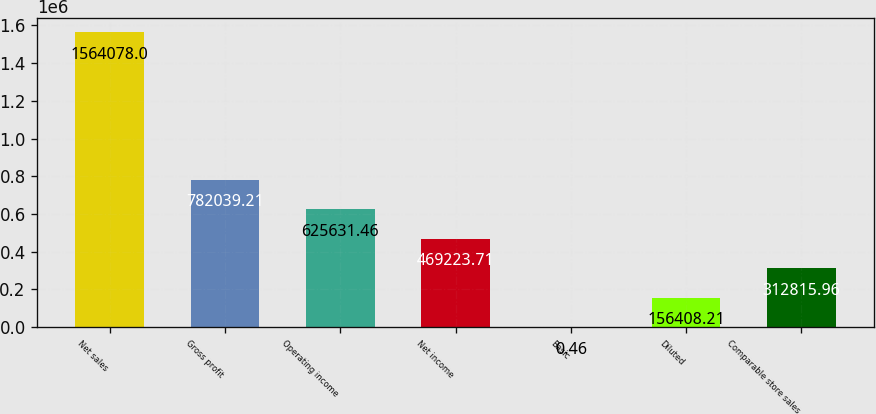<chart> <loc_0><loc_0><loc_500><loc_500><bar_chart><fcel>Net sales<fcel>Gross profit<fcel>Operating income<fcel>Net income<fcel>Basic<fcel>Diluted<fcel>Comparable store sales<nl><fcel>1.56408e+06<fcel>782039<fcel>625631<fcel>469224<fcel>0.46<fcel>156408<fcel>312816<nl></chart> 